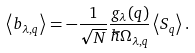Convert formula to latex. <formula><loc_0><loc_0><loc_500><loc_500>\left \langle b _ { \lambda , { q } } \right \rangle = - \frac { 1 } { \sqrt { N } } \frac { g _ { \lambda } ( { q } ) } { \hbar { \Omega } _ { \lambda , { q } } } \left \langle S _ { q } \right \rangle .</formula> 